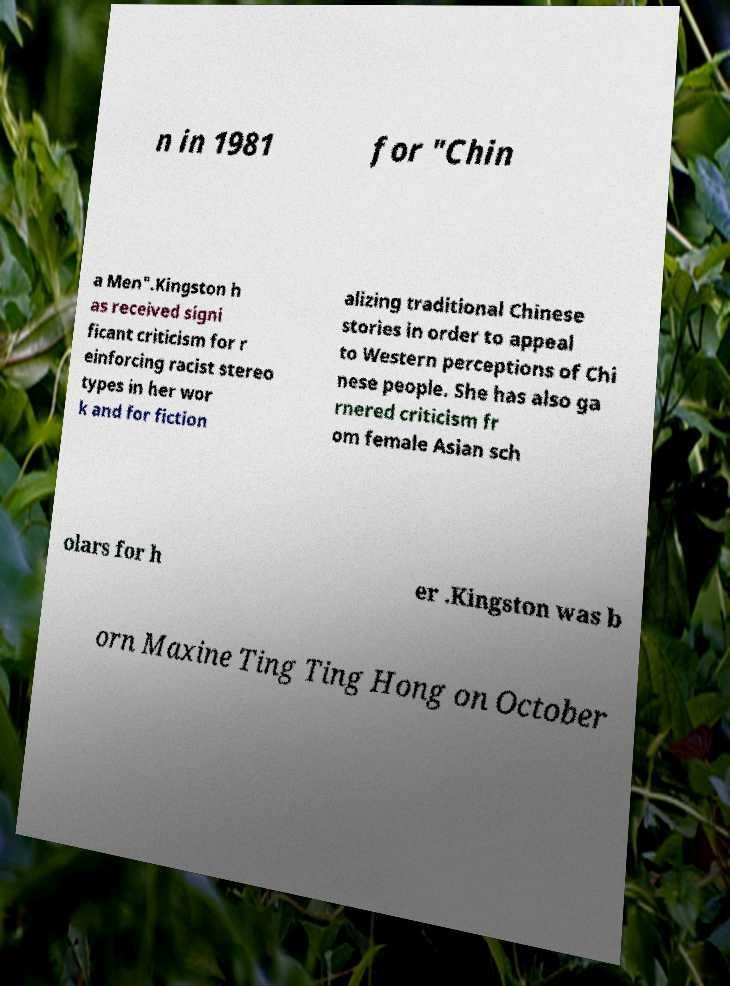For documentation purposes, I need the text within this image transcribed. Could you provide that? n in 1981 for "Chin a Men".Kingston h as received signi ficant criticism for r einforcing racist stereo types in her wor k and for fiction alizing traditional Chinese stories in order to appeal to Western perceptions of Chi nese people. She has also ga rnered criticism fr om female Asian sch olars for h er .Kingston was b orn Maxine Ting Ting Hong on October 